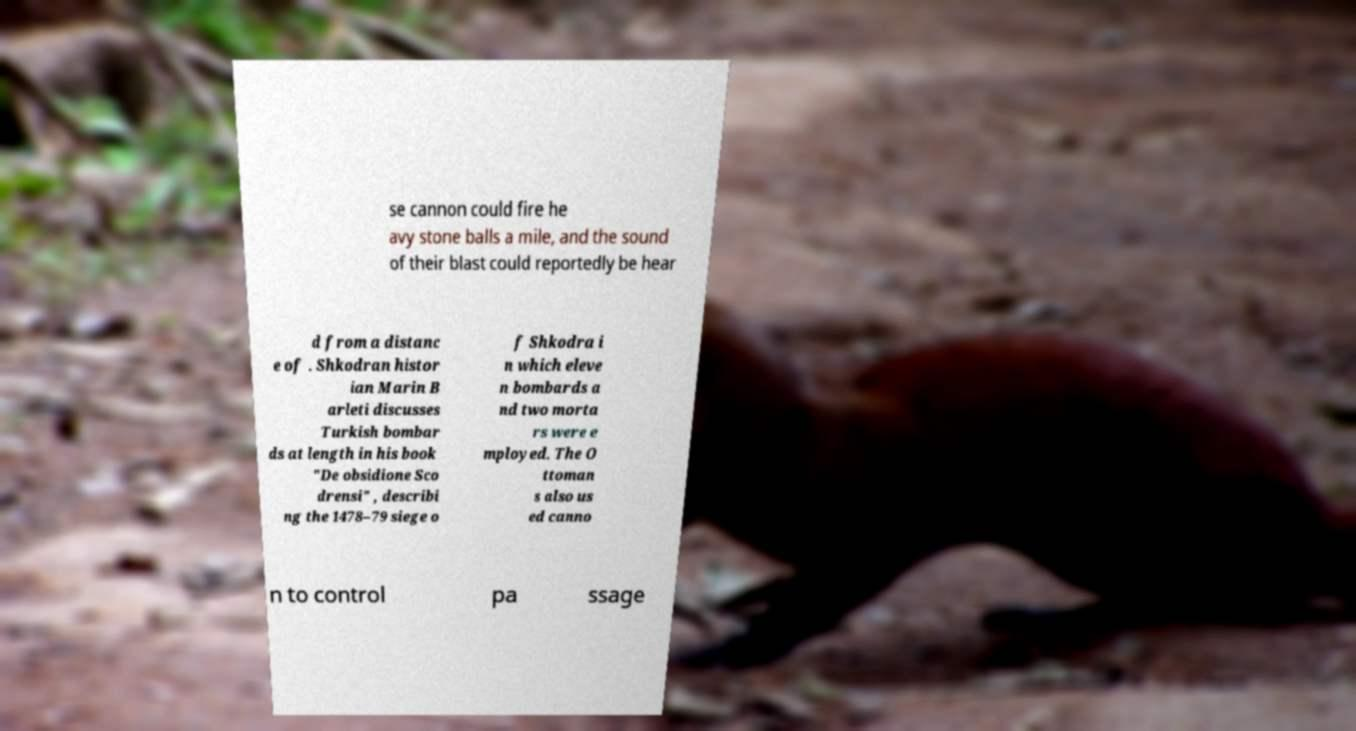Please identify and transcribe the text found in this image. se cannon could fire he avy stone balls a mile, and the sound of their blast could reportedly be hear d from a distanc e of . Shkodran histor ian Marin B arleti discusses Turkish bombar ds at length in his book "De obsidione Sco drensi" , describi ng the 1478–79 siege o f Shkodra i n which eleve n bombards a nd two morta rs were e mployed. The O ttoman s also us ed canno n to control pa ssage 